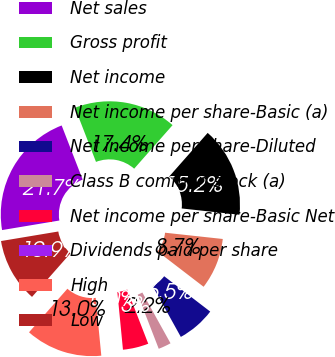Convert chart to OTSL. <chart><loc_0><loc_0><loc_500><loc_500><pie_chart><fcel>Net sales<fcel>Gross profit<fcel>Net income<fcel>Net income per share-Basic (a)<fcel>Net income per share-Diluted<fcel>Class B common stock (a)<fcel>Net income per share-Basic Net<fcel>Dividends paid per share<fcel>High<fcel>Low<nl><fcel>21.74%<fcel>17.39%<fcel>15.22%<fcel>8.7%<fcel>6.52%<fcel>2.17%<fcel>4.35%<fcel>0.0%<fcel>13.04%<fcel>10.87%<nl></chart> 